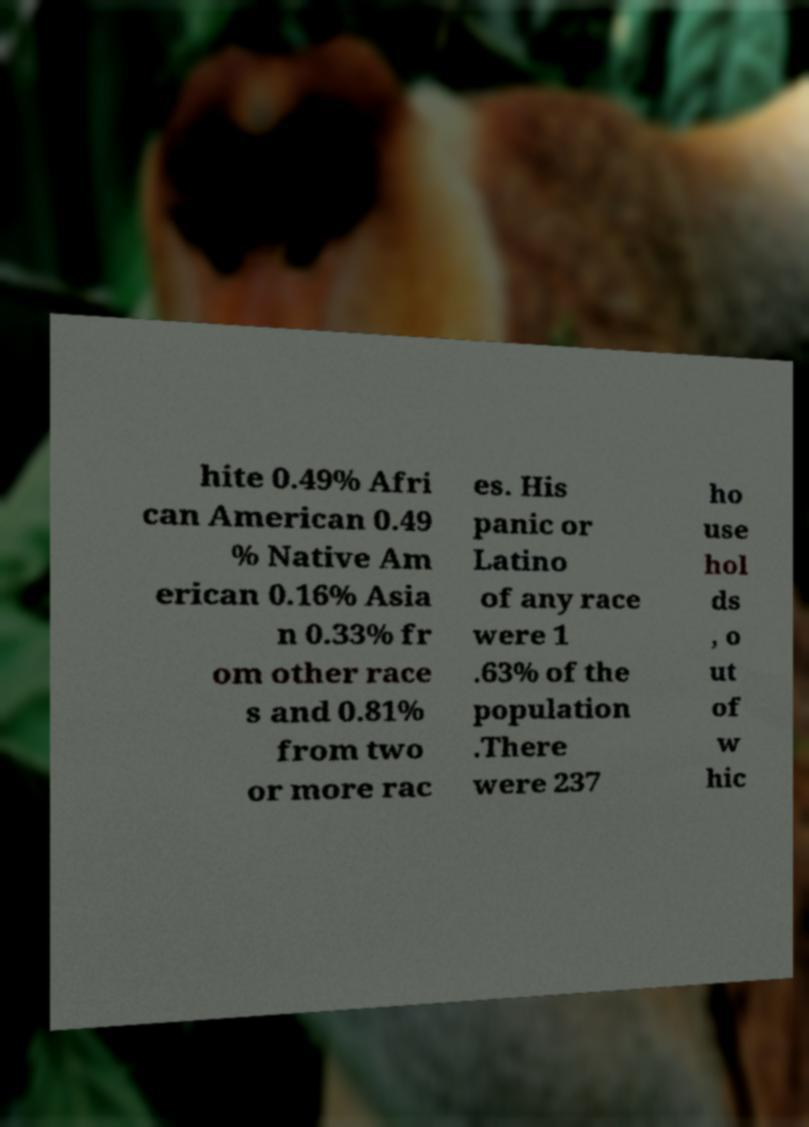What messages or text are displayed in this image? I need them in a readable, typed format. hite 0.49% Afri can American 0.49 % Native Am erican 0.16% Asia n 0.33% fr om other race s and 0.81% from two or more rac es. His panic or Latino of any race were 1 .63% of the population .There were 237 ho use hol ds , o ut of w hic 